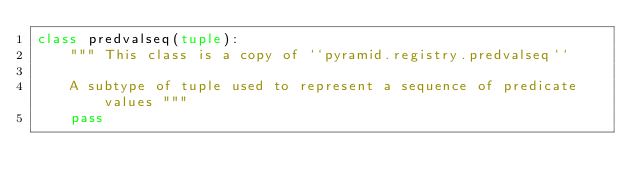Convert code to text. <code><loc_0><loc_0><loc_500><loc_500><_Python_>class predvalseq(tuple):
    """ This class is a copy of ``pyramid.registry.predvalseq``

    A subtype of tuple used to represent a sequence of predicate values """
    pass
</code> 